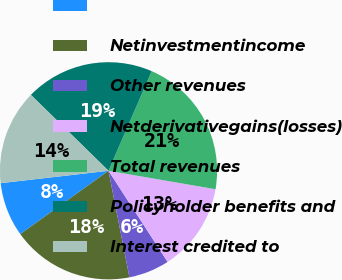<chart> <loc_0><loc_0><loc_500><loc_500><pie_chart><ecel><fcel>Netinvestmentincome<fcel>Other revenues<fcel>Netderivativegains(losses)<fcel>Total revenues<fcel>Policyholder benefits and<fcel>Interest credited to<nl><fcel>8.09%<fcel>18.18%<fcel>6.07%<fcel>13.13%<fcel>21.21%<fcel>19.19%<fcel>14.14%<nl></chart> 